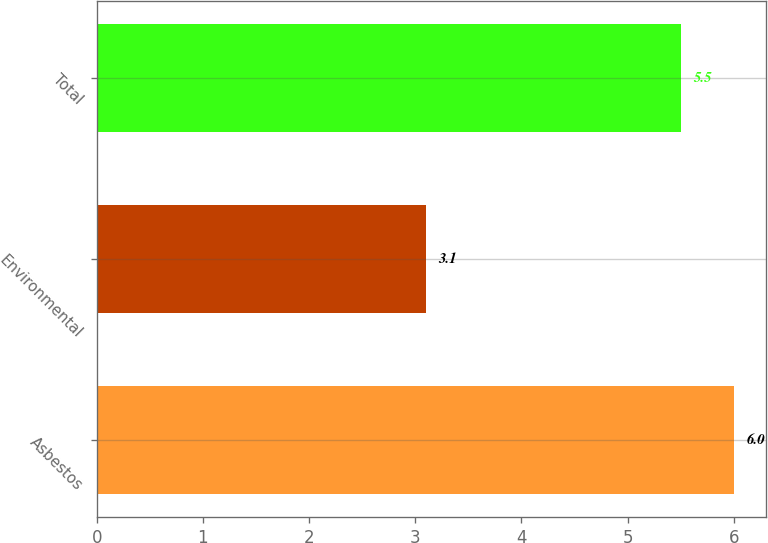Convert chart. <chart><loc_0><loc_0><loc_500><loc_500><bar_chart><fcel>Asbestos<fcel>Environmental<fcel>Total<nl><fcel>6<fcel>3.1<fcel>5.5<nl></chart> 